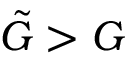Convert formula to latex. <formula><loc_0><loc_0><loc_500><loc_500>\tilde { G } > G</formula> 